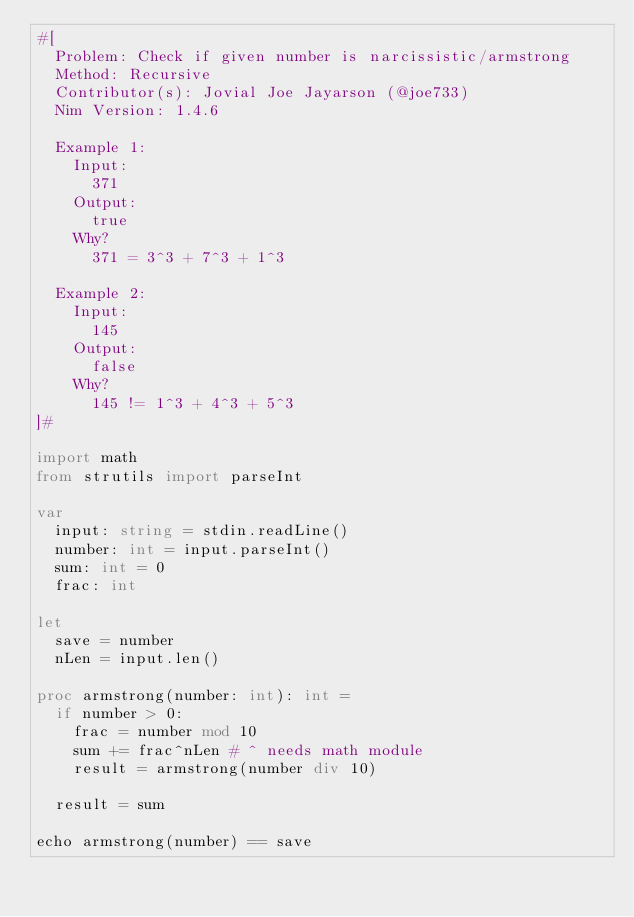<code> <loc_0><loc_0><loc_500><loc_500><_Nim_>#[
  Problem: Check if given number is narcissistic/armstrong
  Method: Recursive
  Contributor(s): Jovial Joe Jayarson (@joe733)
  Nim Version: 1.4.6

  Example 1:
    Input:
      371
    Output:
      true
    Why?
      371 = 3^3 + 7^3 + 1^3
  
  Example 2:
    Input:
      145
    Output:
      false
    Why?
      145 != 1^3 + 4^3 + 5^3
]#

import math
from strutils import parseInt

var
  input: string = stdin.readLine()
  number: int = input.parseInt()
  sum: int = 0
  frac: int

let
  save = number
  nLen = input.len()

proc armstrong(number: int): int =
  if number > 0:
    frac = number mod 10
    sum += frac^nLen # ^ needs math module
    result = armstrong(number div 10)
  
  result = sum

echo armstrong(number) == save
</code> 